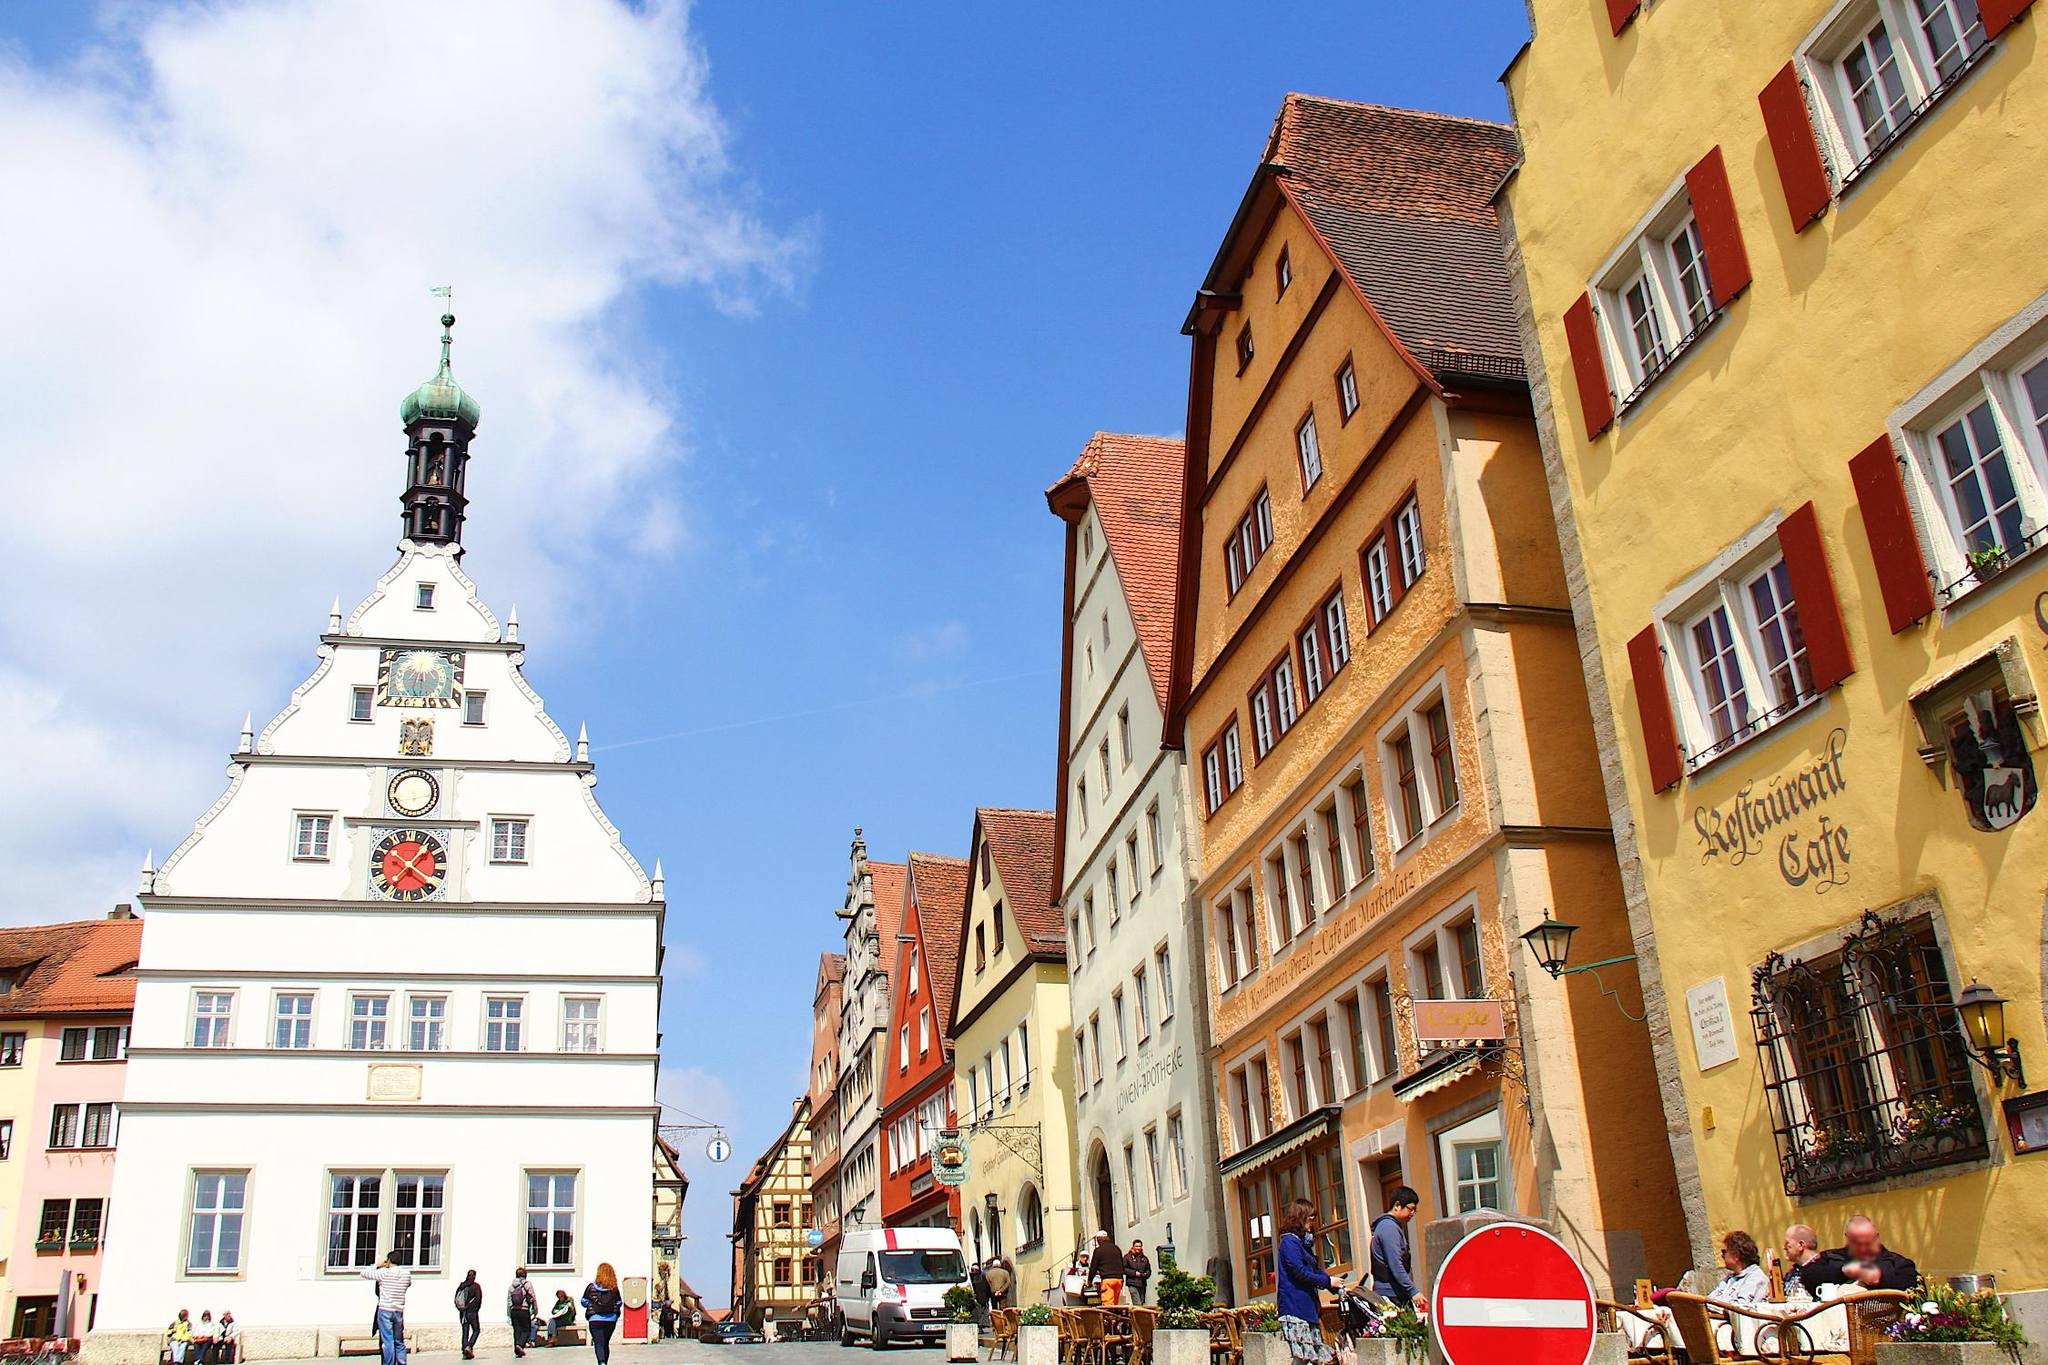What's happening in the scene?
 The image captures a vibrant scene from a street in Rothenburg ob der Tauber, Germany. The street, bustling with people, is framed by buildings painted in cheerful hues of yellow and red, with occasional white and green accents adding to the color palette. Some of these buildings boast ornate architectural details, lending an air of historical charm to the scene. 

On the right side of the photo, a café invites passersby to take a break and enjoy the lively atmosphere. The sky above is a clear blue, with a few clouds scattered across it, adding depth to the expansive backdrop. The perspective of the image is from ground level, looking upwards, which enhances the grandeur of the buildings and the sky. The landmark identifier 'sa_1319' doesn't provide additional information about this specific location. 